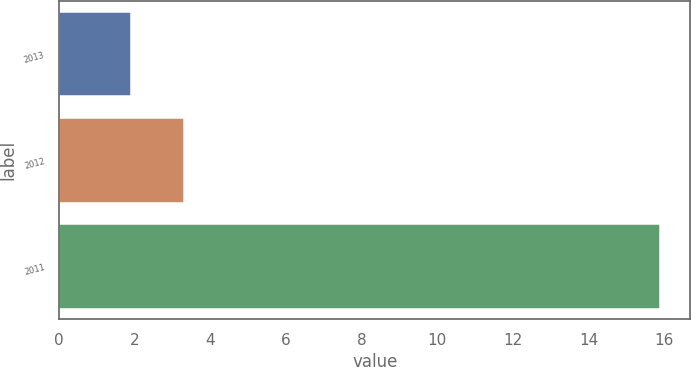<chart> <loc_0><loc_0><loc_500><loc_500><bar_chart><fcel>2013<fcel>2012<fcel>2011<nl><fcel>1.9<fcel>3.3<fcel>15.9<nl></chart> 